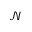Convert formula to latex. <formula><loc_0><loc_0><loc_500><loc_500>\mathcal { N }</formula> 